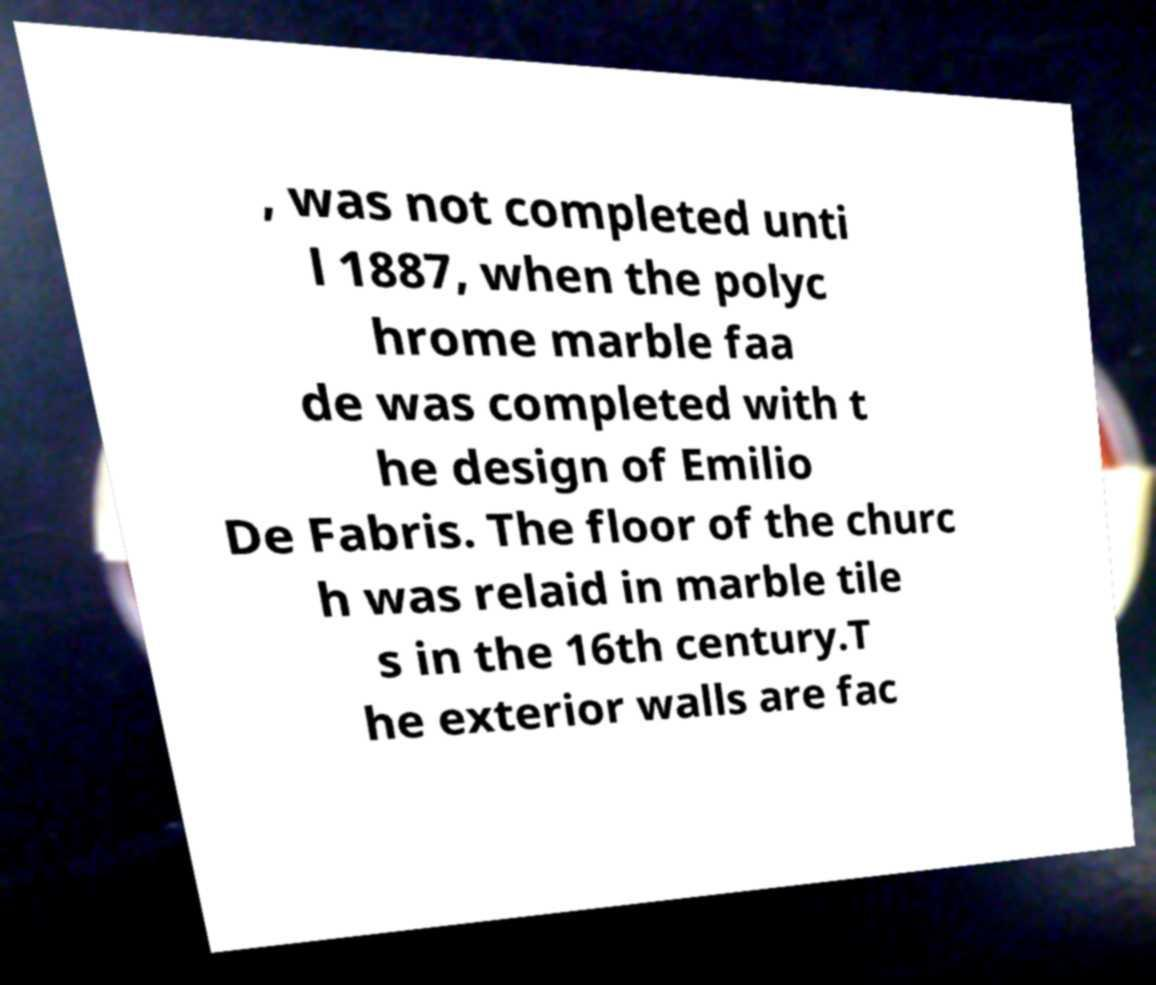I need the written content from this picture converted into text. Can you do that? , was not completed unti l 1887, when the polyc hrome marble faa de was completed with t he design of Emilio De Fabris. The floor of the churc h was relaid in marble tile s in the 16th century.T he exterior walls are fac 